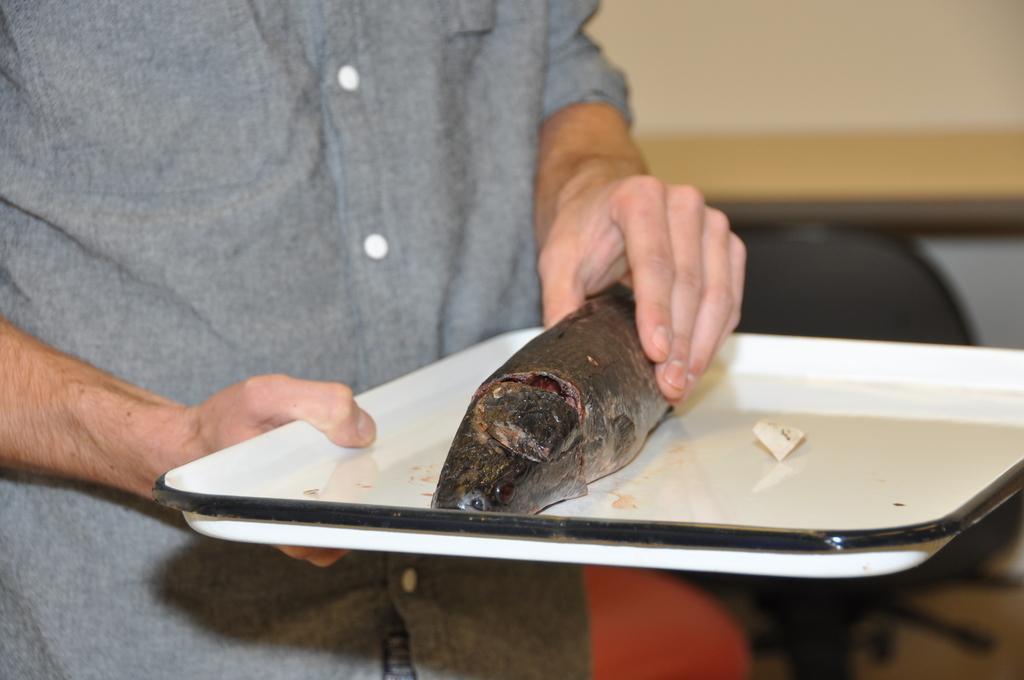Please provide a concise description of this image. In this image I can see a person holding a white tray which contains fish. The background is blurred. 